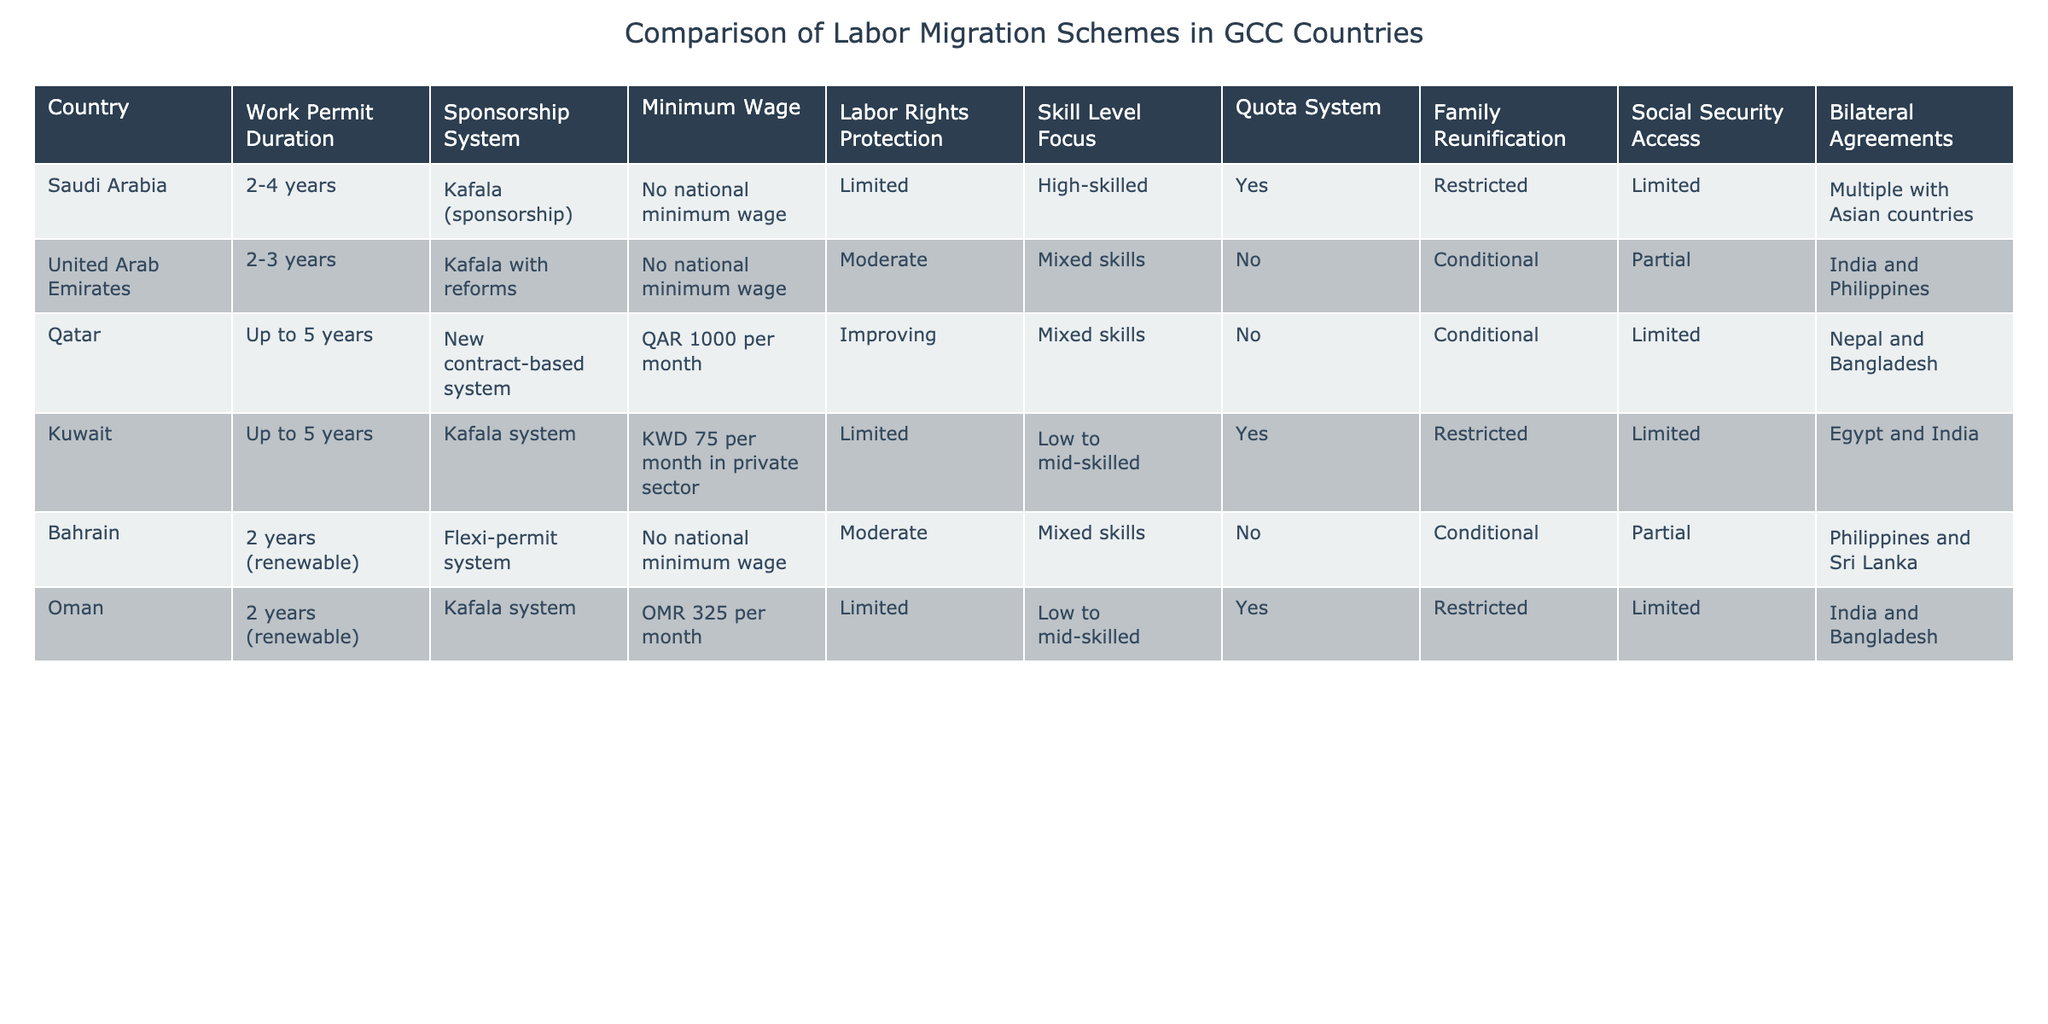What is the work permit duration for Qatar? The table indicates that Qatar allows a work permit duration of up to 5 years.
Answer: Up to 5 years Which country has a minimum wage of KWD 75 per month in the private sector? The table shows that Kuwait has a minimum wage of KWD 75 per month specifically in the private sector.
Answer: Kuwait How many countries have a quota system in place for labor migration? By examining the table, it is clear that Saudi Arabia, Kuwait, and Oman have a quota system, making a total of 3 countries with such a system.
Answer: 3 Is social security access fully available in the United Arab Emirates? According to the table, the United Arab Emirates has partial social security access, which indicates it is not fully available.
Answer: No Which country focuses on high-skilled labor and has multiple bilateral agreements with Asian countries? The table reveals that Saudi Arabia focuses on high-skilled labor and has multiple bilateral agreements, mainly with Asian countries.
Answer: Saudi Arabia What is the average minimum wage across the GCC countries listed in the table? First, I calculate the minimum wage values where available: Qatar (QAR 1000), Kuwait (KWD 75), and Oman (OMR 325). For QAR 1000, KWD 75 is approximately QAR 1100, and OMR 325 is around QAR 850. Adding these up: 1000 + 1100 + 850 = 2950 and dividing this by 3 gives an average of approximately 983.33. Therefore, the average minimum wage is approximately QAR 983.33.
Answer: Approximately QAR 983.33 Does Bahrain have a flexible family reunification policy? The table indicates that family reunification in Bahrain is conditional, which implies that it is not fully flexible.
Answer: No Which country has improved labor rights protection compared to the others? The table highlights that Qatar is noted as improving in labor rights protection when compared to other countries that range from limited to moderate levels of protection.
Answer: Qatar What is the difference in work permit duration between Saudi Arabia and Oman? The work permit duration for Saudi Arabia is 2-4 years, while Oman allows for 2 years (renewable). The longest duration (4 years from Saudi Arabia) minus the longest for Oman (2 years) results in a difference of 2 years.
Answer: 2 years 